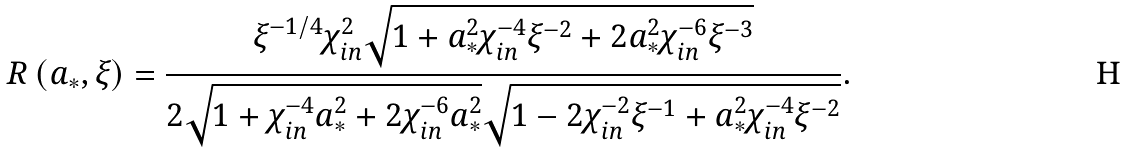Convert formula to latex. <formula><loc_0><loc_0><loc_500><loc_500>R \left ( { a _ { * } , \xi } \right ) = \frac { \xi ^ { - 1 / 4 } \chi _ { i n } ^ { 2 } \sqrt { 1 + a _ { * } ^ { 2 } \chi _ { i n } ^ { - 4 } \xi ^ { - 2 } + 2 a _ { * } ^ { 2 } \chi _ { i n } ^ { - 6 } \xi ^ { - 3 } } } { 2 \sqrt { 1 + \chi _ { i n } ^ { - 4 } a _ { * } ^ { 2 } + 2 \chi _ { i n } ^ { - 6 } a _ { * } ^ { 2 } } \sqrt { 1 - 2 \chi _ { i n } ^ { - 2 } \xi ^ { - 1 } + a _ { * } ^ { 2 } \chi _ { i n } ^ { - 4 } \xi ^ { - 2 } } } .</formula> 